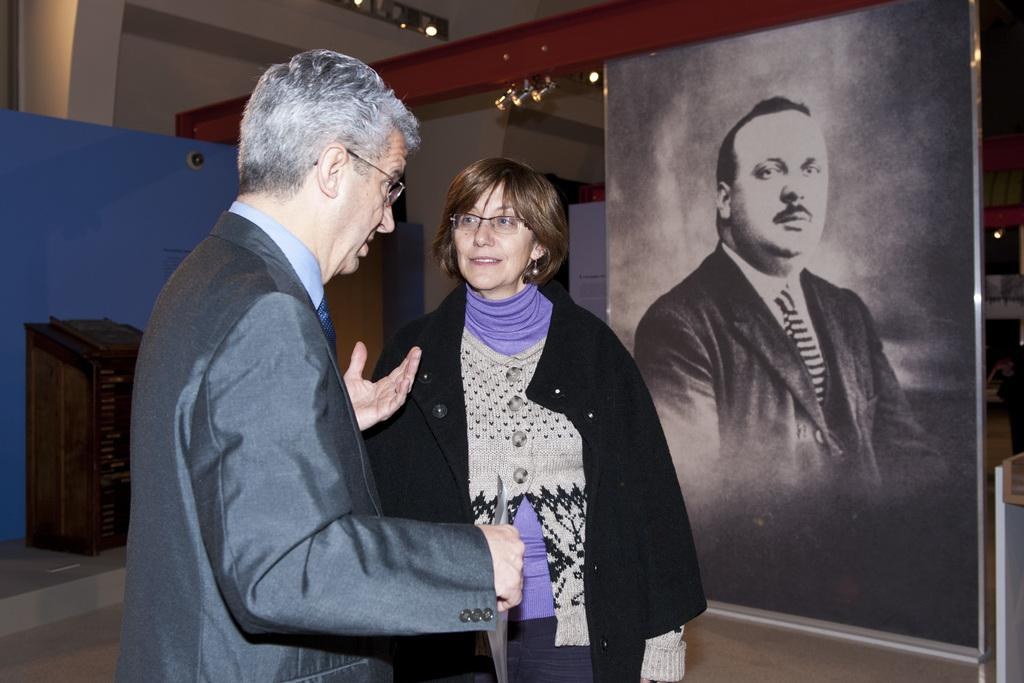What is the person in the image wearing? The person in the image is wearing a suit. What is the person in the suit doing? The person is standing and speaking. Is there anyone else in the image besides the person in the suit? Yes, there is a woman standing beside the person in the suit. What can be seen in the right corner of the image? There is a picture of a person in the right corner of the image. Where is the faucet located in the image? There is no faucet present in the image. How does the person in the suit stretch their arms in the image? The person in the suit is not stretching their arms in the image; they are standing and speaking. 